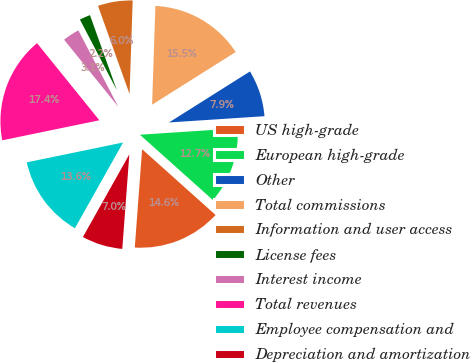Convert chart. <chart><loc_0><loc_0><loc_500><loc_500><pie_chart><fcel>US high-grade<fcel>European high-grade<fcel>Other<fcel>Total commissions<fcel>Information and user access<fcel>License fees<fcel>Interest income<fcel>Total revenues<fcel>Employee compensation and<fcel>Depreciation and amortization<nl><fcel>14.57%<fcel>12.66%<fcel>7.91%<fcel>15.52%<fcel>6.0%<fcel>2.2%<fcel>3.15%<fcel>17.42%<fcel>13.62%<fcel>6.96%<nl></chart> 